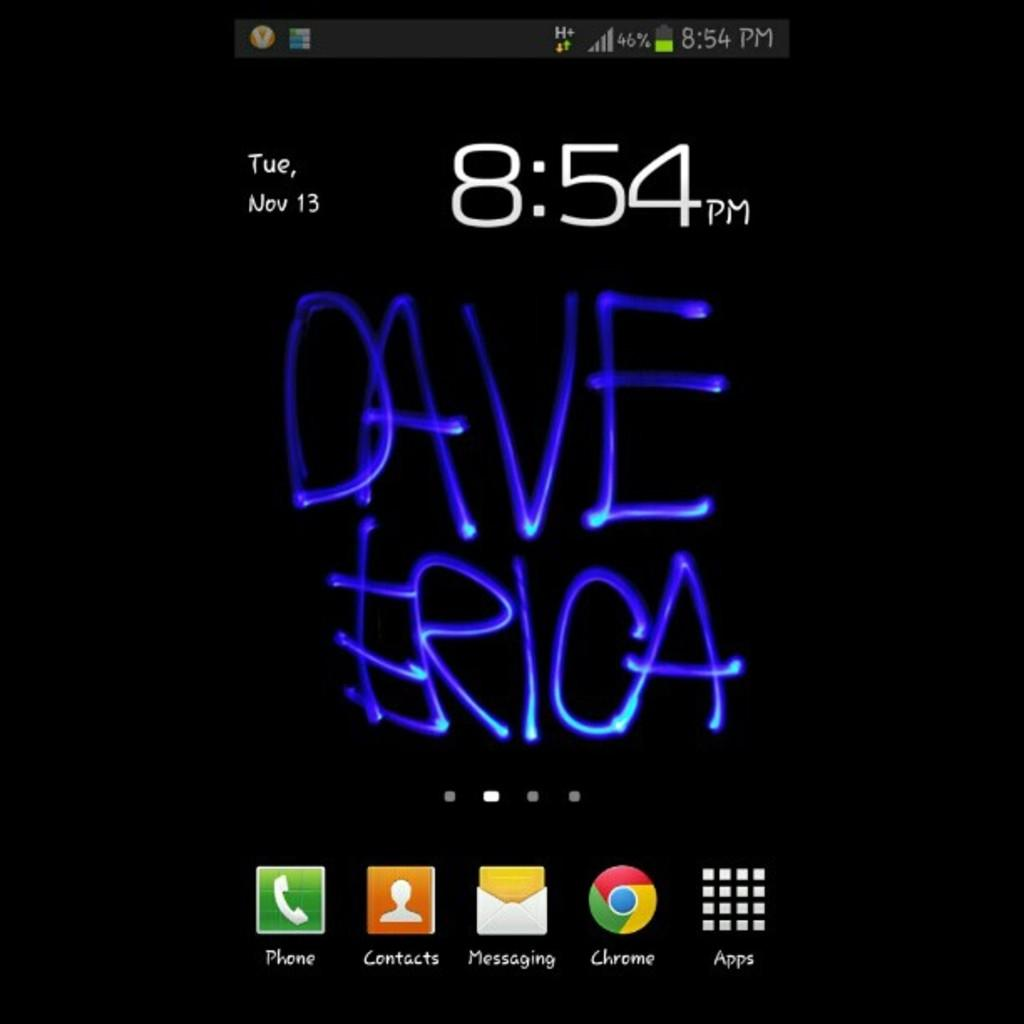<image>
Present a compact description of the photo's key features. Dave and Erica's names are written below the time, which is 8:54 pm. 